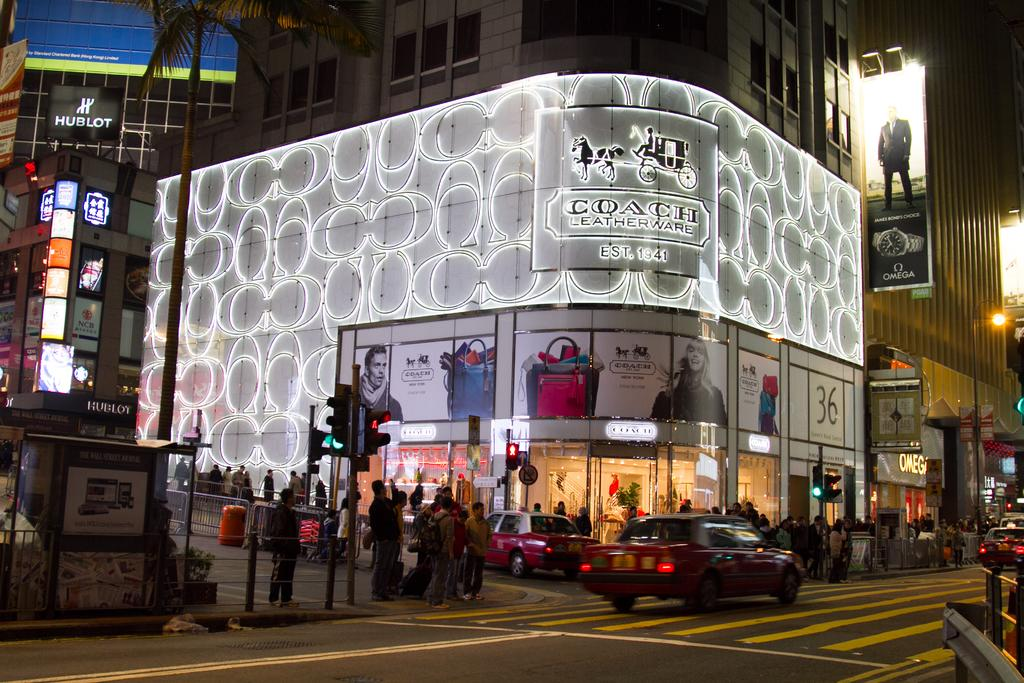<image>
Create a compact narrative representing the image presented. the word coach that is on a building outside 